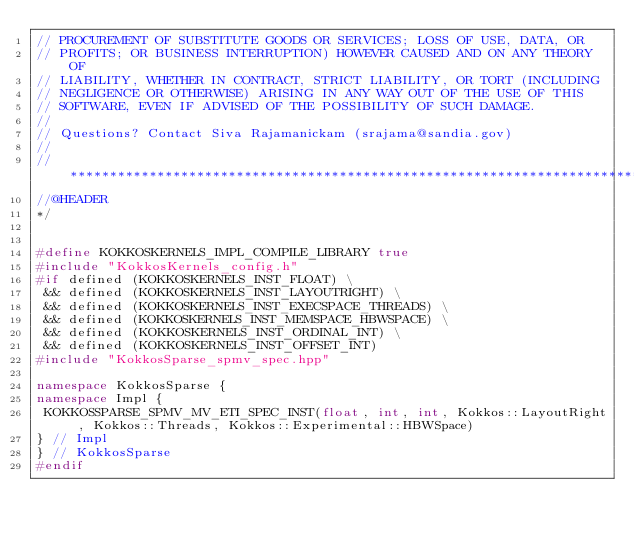Convert code to text. <code><loc_0><loc_0><loc_500><loc_500><_C++_>// PROCUREMENT OF SUBSTITUTE GOODS OR SERVICES; LOSS OF USE, DATA, OR
// PROFITS; OR BUSINESS INTERRUPTION) HOWEVER CAUSED AND ON ANY THEORY OF
// LIABILITY, WHETHER IN CONTRACT, STRICT LIABILITY, OR TORT (INCLUDING
// NEGLIGENCE OR OTHERWISE) ARISING IN ANY WAY OUT OF THE USE OF THIS
// SOFTWARE, EVEN IF ADVISED OF THE POSSIBILITY OF SUCH DAMAGE.
//
// Questions? Contact Siva Rajamanickam (srajama@sandia.gov)
//
// ************************************************************************
//@HEADER
*/


#define KOKKOSKERNELS_IMPL_COMPILE_LIBRARY true
#include "KokkosKernels_config.h"
#if defined (KOKKOSKERNELS_INST_FLOAT) \
 && defined (KOKKOSKERNELS_INST_LAYOUTRIGHT) \
 && defined (KOKKOSKERNELS_INST_EXECSPACE_THREADS) \
 && defined (KOKKOSKERNELS_INST_MEMSPACE_HBWSPACE) \
 && defined (KOKKOSKERNELS_INST_ORDINAL_INT) \
 && defined (KOKKOSKERNELS_INST_OFFSET_INT) 
#include "KokkosSparse_spmv_spec.hpp"

namespace KokkosSparse {
namespace Impl {
 KOKKOSSPARSE_SPMV_MV_ETI_SPEC_INST(float, int, int, Kokkos::LayoutRight, Kokkos::Threads, Kokkos::Experimental::HBWSpace)
} // Impl
} // KokkosSparse
#endif
</code> 